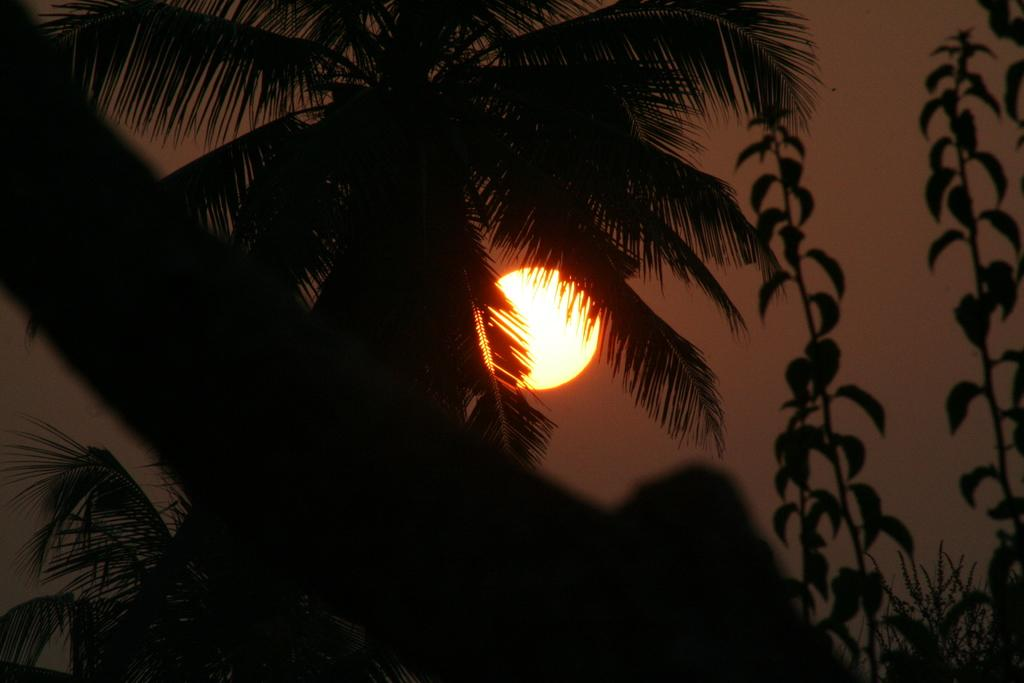What type of vegetation can be seen in the image? There are trees in the image. What part of the natural environment is visible in the image? The sky is visible in the background of the image. Can you see a bat flying in the hall in the image? There is no hall or bat present in the image; it features trees and the sky. 